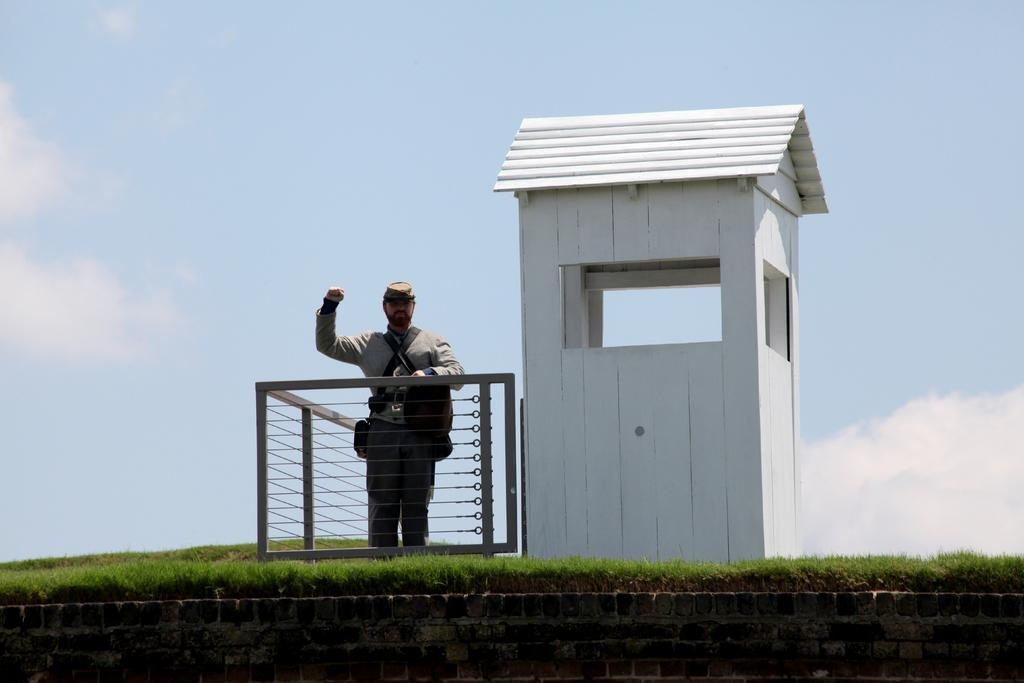What is the main subject of the image? There is a man standing in the image. What is the man wearing on his head? The man is wearing a cap. What type of terrain is visible in the image? There is grass visible in the image. What type of structure can be seen in the image? There is a white-colored shaded shack in the image. What is visible in the sky in the image? There are clouds visible in the image, and the sky is also visible. What type of grain is being harvested in the image? There is no grain or harvesting activity present in the image. What color is the comb used by the man in the image? There is no comb visible in the image. 